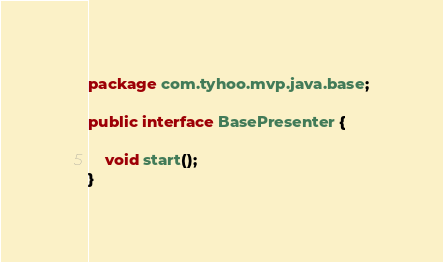<code> <loc_0><loc_0><loc_500><loc_500><_Java_>package com.tyhoo.mvp.java.base;

public interface BasePresenter {

    void start();
}
</code> 